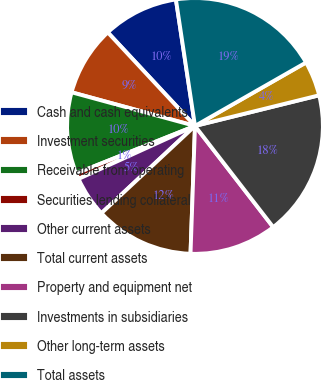<chart> <loc_0><loc_0><loc_500><loc_500><pie_chart><fcel>Cash and cash equivalents<fcel>Investment securities<fcel>Receivable from operating<fcel>Securities lending collateral<fcel>Other current assets<fcel>Total current assets<fcel>Property and equipment net<fcel>Investments in subsidiaries<fcel>Other long-term assets<fcel>Total assets<nl><fcel>9.56%<fcel>8.82%<fcel>10.29%<fcel>0.74%<fcel>5.15%<fcel>12.5%<fcel>11.03%<fcel>18.38%<fcel>4.41%<fcel>19.12%<nl></chart> 